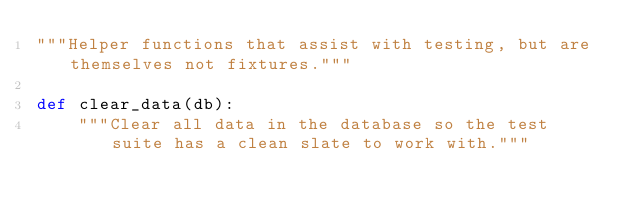Convert code to text. <code><loc_0><loc_0><loc_500><loc_500><_Python_>"""Helper functions that assist with testing, but are themselves not fixtures."""

def clear_data(db):
    """Clear all data in the database so the test suite has a clean slate to work with."""</code> 